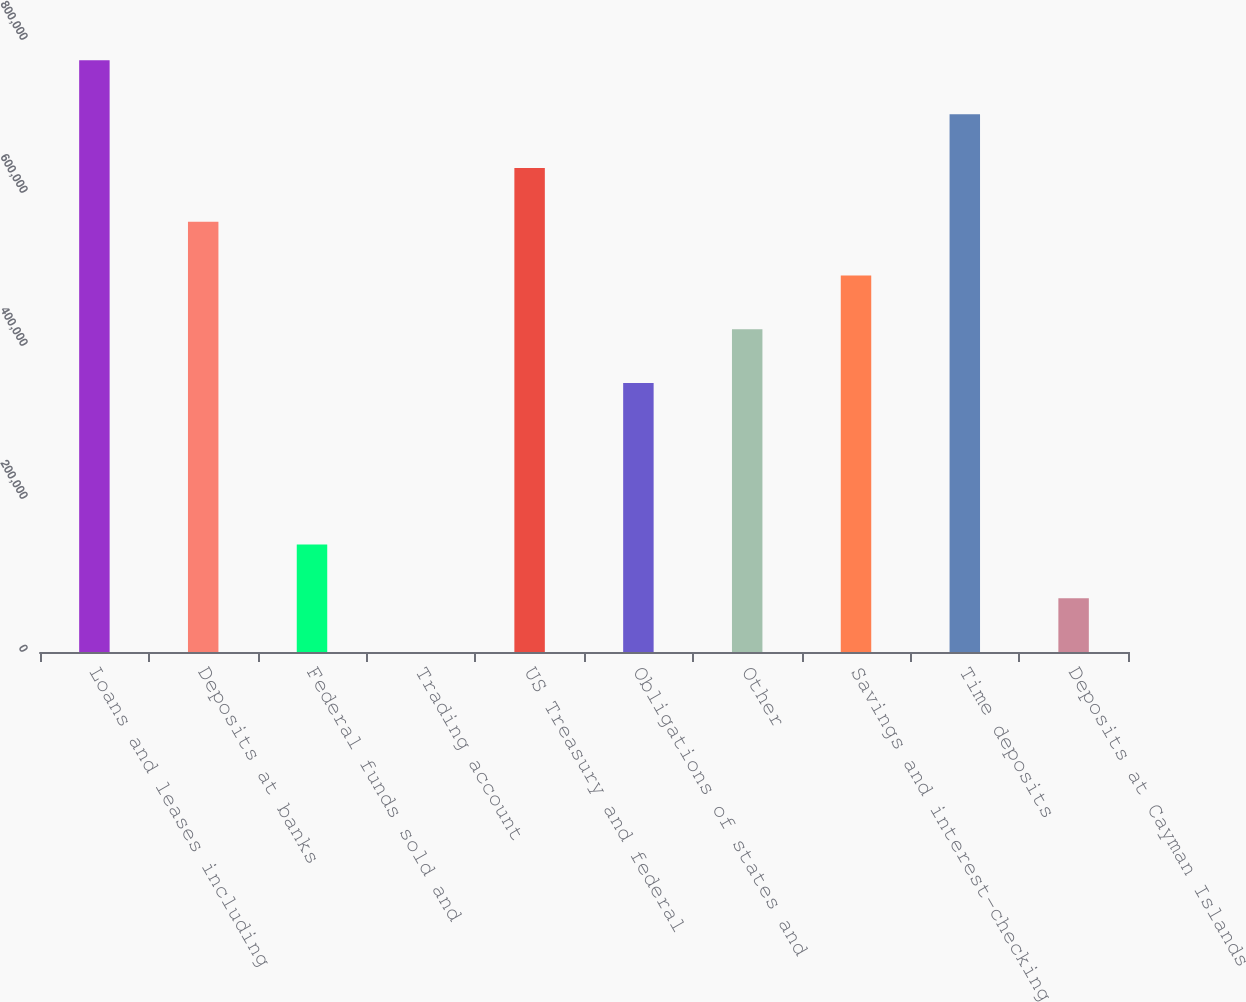Convert chart. <chart><loc_0><loc_0><loc_500><loc_500><bar_chart><fcel>Loans and leases including<fcel>Deposits at banks<fcel>Federal funds sold and<fcel>Trading account<fcel>US Treasury and federal<fcel>Obligations of states and<fcel>Other<fcel>Savings and interest-checking<fcel>Time deposits<fcel>Deposits at Cayman Islands<nl><fcel>773406<fcel>562485<fcel>140645<fcel>31<fcel>632792<fcel>351565<fcel>421872<fcel>492179<fcel>703099<fcel>70337.8<nl></chart> 